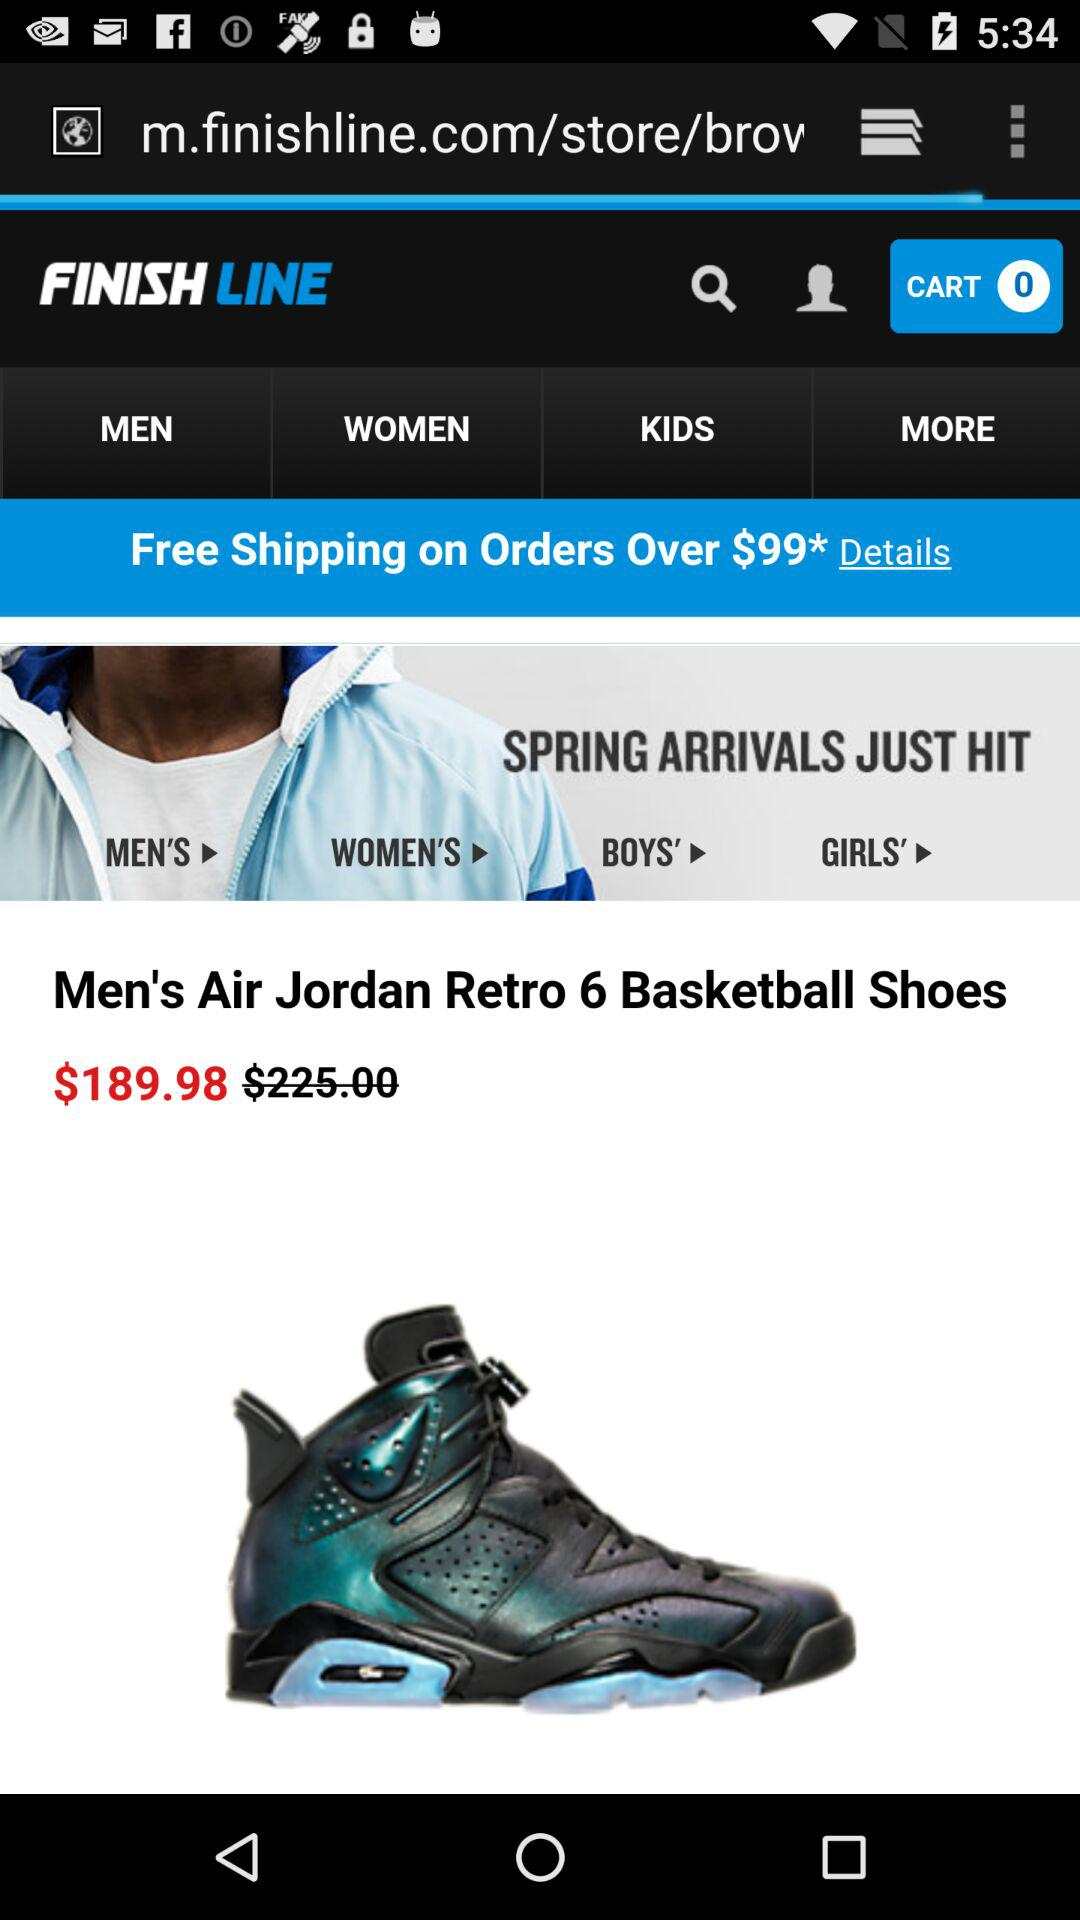What is the discounted price of "Men's Air Jordan Retro 6 Basketball Shoes"? The discounted price is $189.98. 